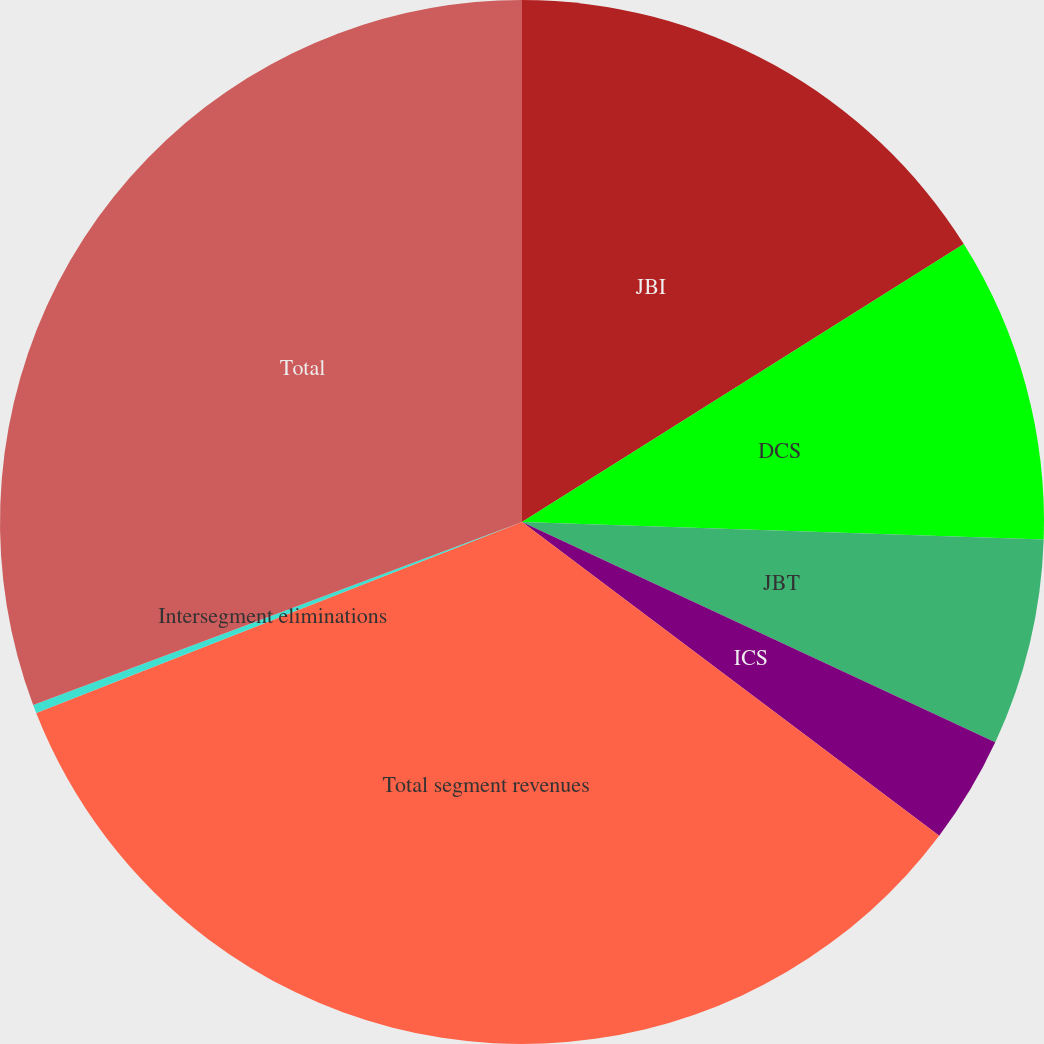Convert chart. <chart><loc_0><loc_0><loc_500><loc_500><pie_chart><fcel>JBI<fcel>DCS<fcel>JBT<fcel>ICS<fcel>Total segment revenues<fcel>Intersegment eliminations<fcel>Total<nl><fcel>16.06%<fcel>9.47%<fcel>6.4%<fcel>3.33%<fcel>33.77%<fcel>0.26%<fcel>30.7%<nl></chart> 